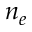<formula> <loc_0><loc_0><loc_500><loc_500>n _ { e }</formula> 